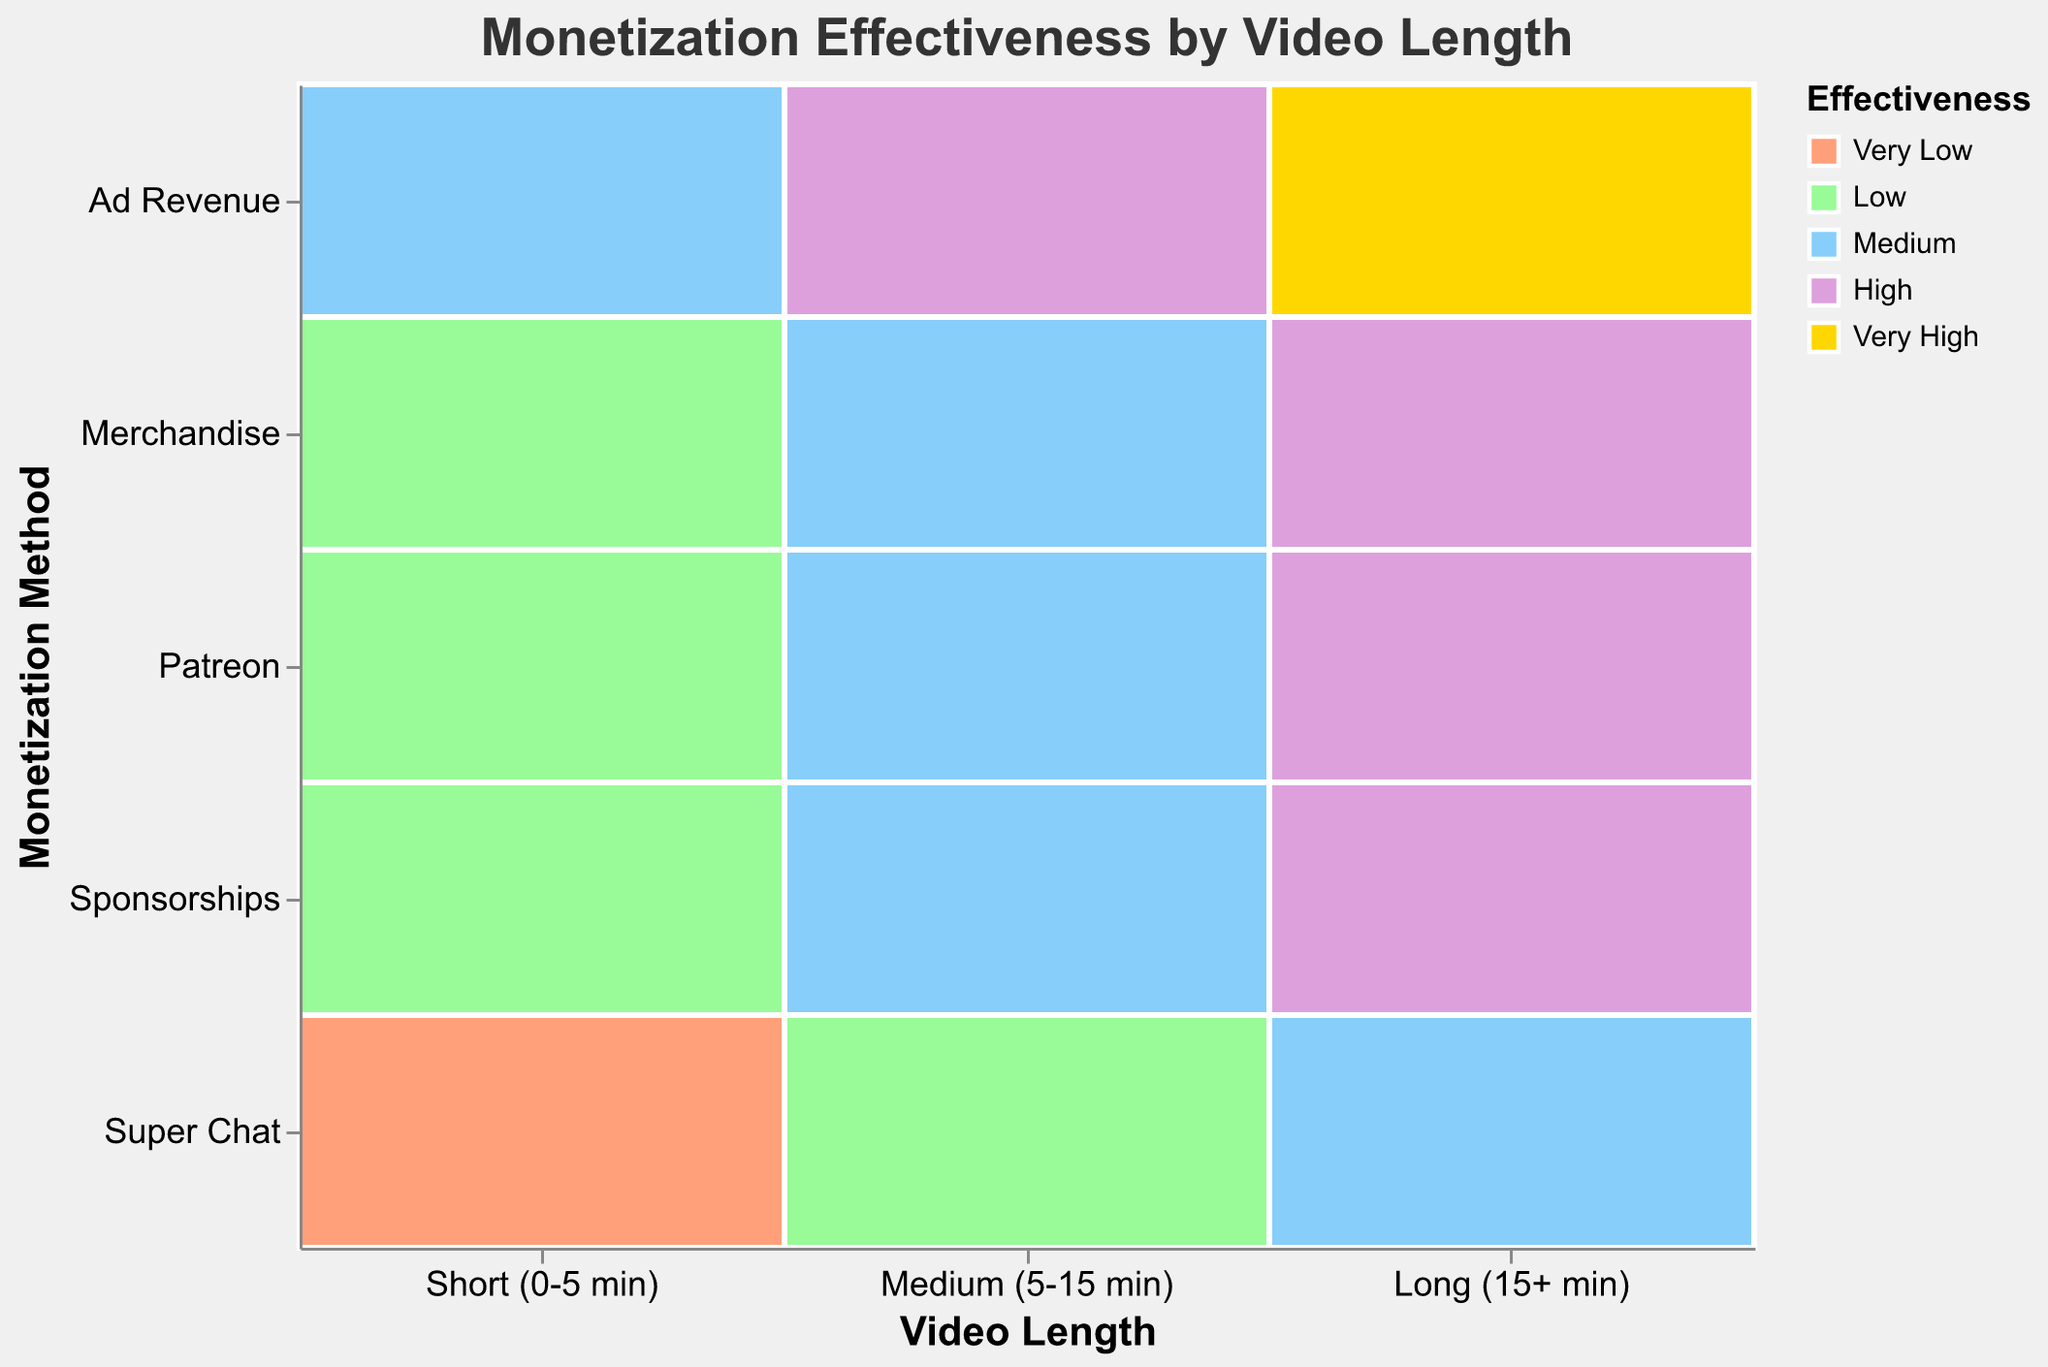What is the title of the plot? The title of the plot is usually displayed at the top of the figure, indicating the overall topic of the visualization. In this case, it reads "Monetization Effectiveness by Video Length."
Answer: Monetization Effectiveness by Video Length Which video length has the highest effectiveness for Ad Revenue? The effectiveness levels are displayed using color coding. By looking at the colors corresponding to Ad Revenue across different video lengths, the darkest color, representing "Very High," can be seen in the "Long (15+ min)" category.
Answer: Long (15+ min) How does the effectiveness of Merchandise change with video length? By examining the colors associated with Merchandise across different video length categories, we can observe how effectiveness varies. For "Short (0-5 min)" and "Medium (5-15 min)," the color represents "Low" and "Medium," respectively. For "Long (15+ min)," it shows "High."
Answer: It increases as the video length increases Which monetization method consistently has the lowest effectiveness regardless of video length? The lowest effectiveness is indicated by the lightest color, which represents "Very Low." By observing the color distribution, "Super Chat" has "Very Low" and "Low" effectiveness in "Short (0-5 min)" and "Medium (5-15 min)," respectively, which indicates lower performance in general.
Answer: Super Chat Compare the effectiveness of Sponsorships and Patreon for "Medium (5-15 min)" videos. For "Medium (5-15 min)" videos, examining the colors associated with Sponsorships and Patreon, Sponsorships is "Medium" and Patreon is also "Medium." Thus, they have equal effectiveness.
Answer: They have equal effectiveness Which monetization method shows the highest effectiveness across all categories? Identifying the highest effectiveness involves spotting the "Very High" color across the video length. The "Ad Revenue" for "Long (15+ min)" is marked "Very High," which is the highest effectiveness across the chart.
Answer: Ad Revenue for Long (15+ min) Is there a monetization method that has "High" effectiveness for all video lengths? "High" effectiveness is denoted by a specific color. By scanning the plot, no single monetization method has "High" effectiveness for all video lengths. Various methods have differing levels of effectiveness.
Answer: No How does the effectiveness of Sponsorships differ between short and long videos? By comparing the effectiveness colors for Sponsorships across "Short (0-5 min)" and "Long (15+ min)" video lengths, we see that it starts as "Low" for short videos and increases to "High" for long videos.
Answer: It increases significantly What is the effectiveness of Patreon for short videos? Checking the color coding for Patreon under the "Short (0-5 min)" category, the color indicates "Low" effectiveness.
Answer: Low 